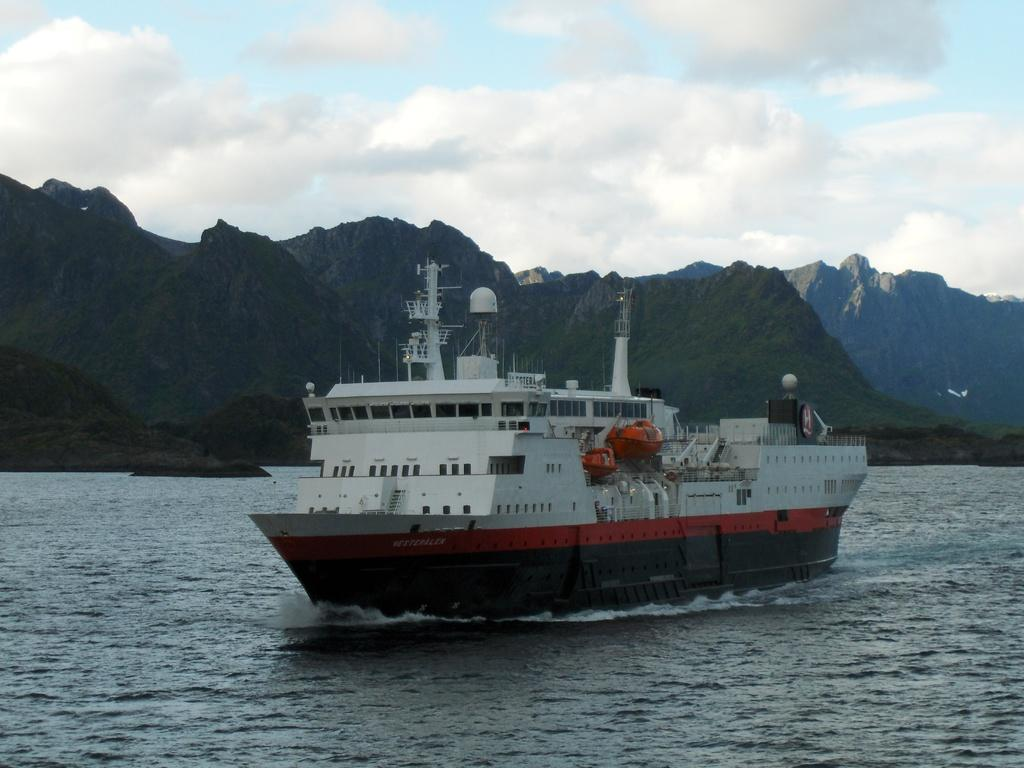What is the main subject of the image? The main subject of the image is a ship. Where is the ship located in the image? The ship is on a river. What can be seen in the background of the image? Mountains and the sky are visible in the background of the image. What type of wealth is depicted in the image? There is no depiction of wealth in the image; it features a ship on a river with mountains and the sky in the background. What belief system is being represented in the image? There is no specific belief system being represented in the image; it simply shows a ship on a river with mountains and the sky in the background. 